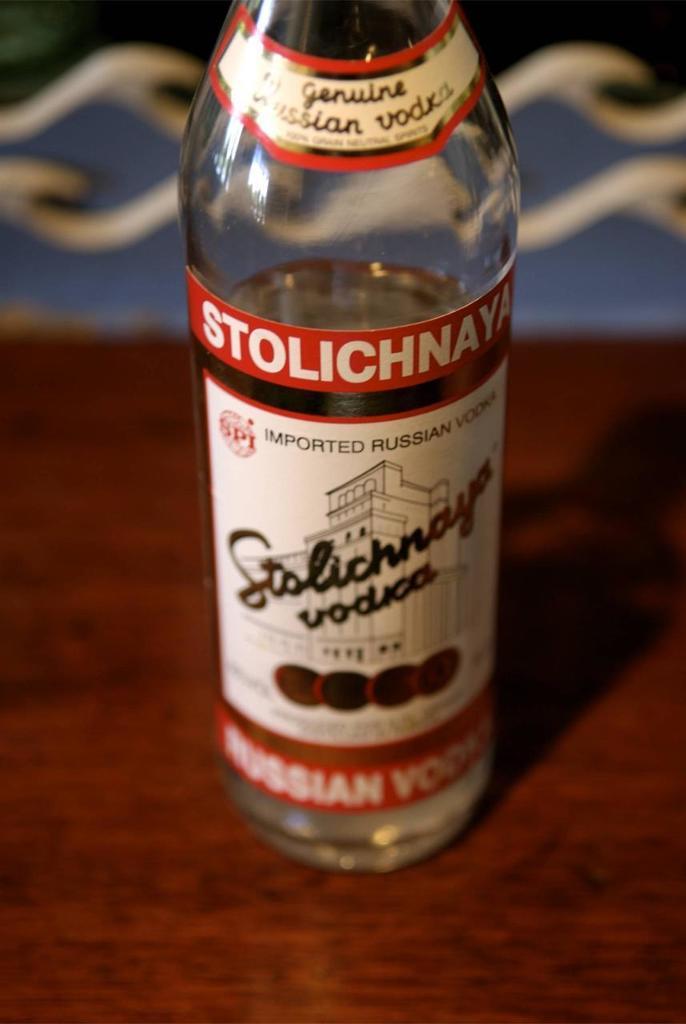What brand of vodka is this?
Offer a terse response. Stolichnaya. 